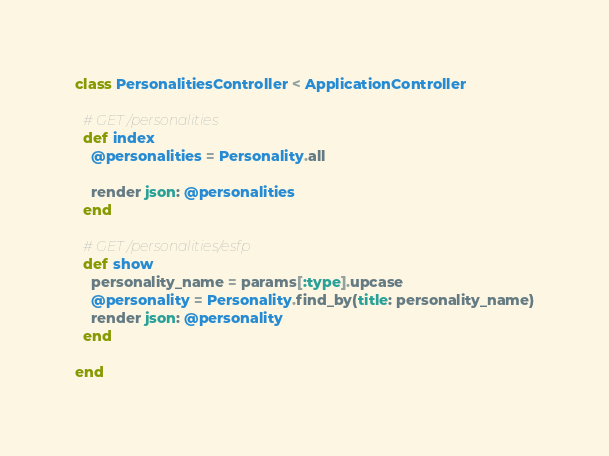Convert code to text. <code><loc_0><loc_0><loc_500><loc_500><_Ruby_>class PersonalitiesController < ApplicationController

  # GET /personalities
  def index
    @personalities = Personality.all

    render json: @personalities
  end

  # GET /personalities/esfp
  def show
    personality_name = params[:type].upcase
    @personality = Personality.find_by(title: personality_name)
    render json: @personality
  end

end
</code> 